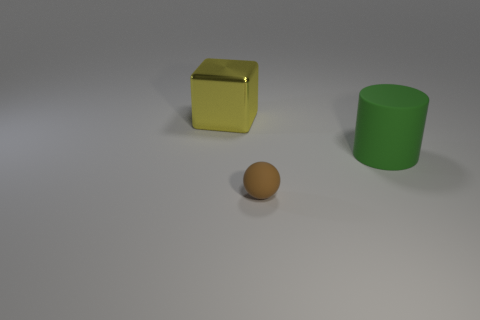Is the material of the yellow object the same as the large thing on the right side of the tiny brown rubber thing?
Provide a short and direct response. No. What is the material of the brown thing?
Ensure brevity in your answer.  Rubber. What is the material of the big object that is left of the object in front of the large object that is in front of the large block?
Your answer should be very brief. Metal. There is a matte thing that is to the left of the big green object; does it have the same size as the thing that is behind the green rubber cylinder?
Your answer should be very brief. No. How many other things are made of the same material as the big green cylinder?
Offer a very short reply. 1. What number of metal objects are either big cyan cylinders or yellow cubes?
Your answer should be compact. 1. Are there fewer yellow blocks than tiny brown metallic balls?
Offer a terse response. No. Is the size of the ball the same as the yellow block behind the big rubber thing?
Offer a very short reply. No. What is the size of the brown sphere?
Your answer should be compact. Small. Are there fewer metallic things that are right of the tiny brown rubber thing than tiny cyan metal cylinders?
Give a very brief answer. No. 